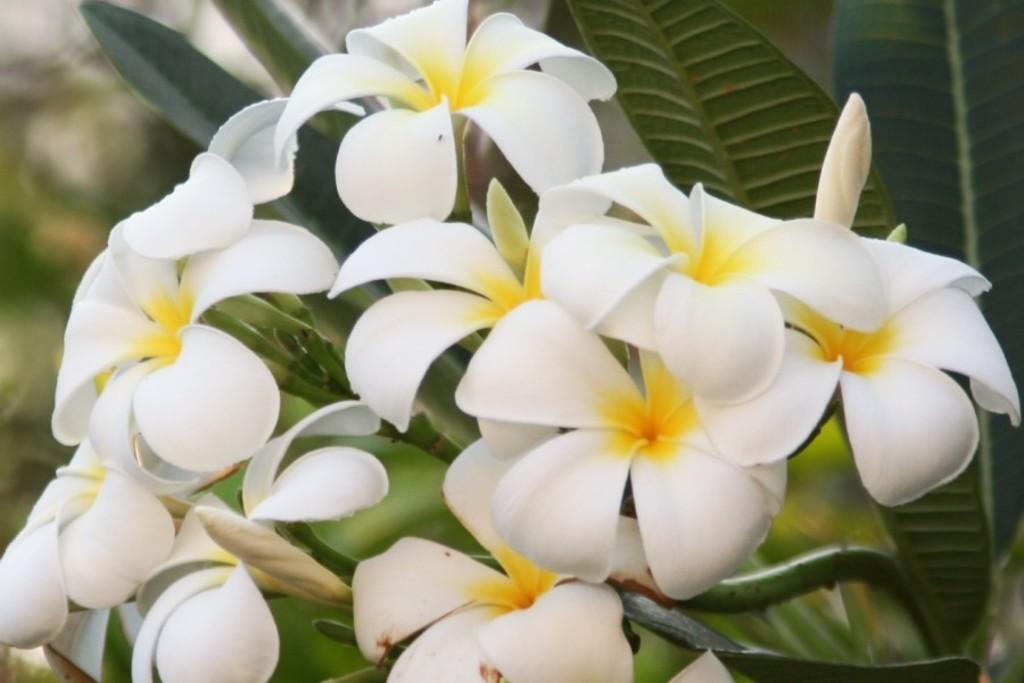Could you give a brief overview of what you see in this image? In the picture we can see plants with a group of flowers to it which are white in color and some yellow part in the middle of the petals of the flower. 